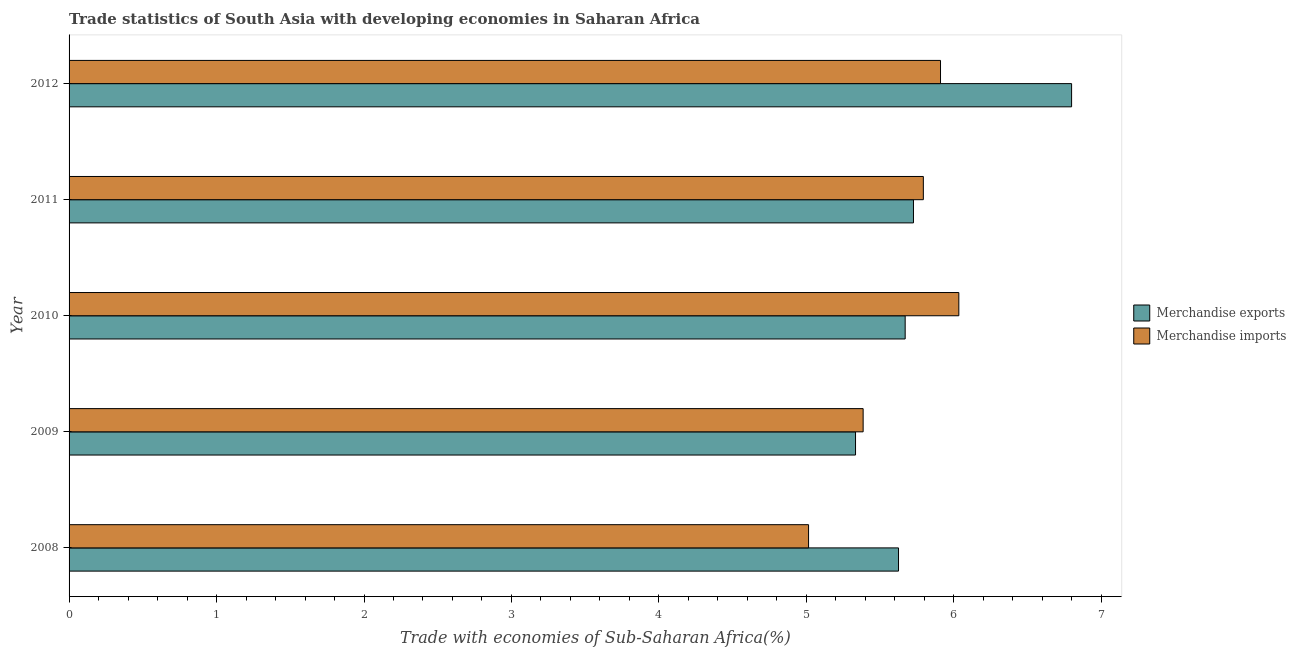How many different coloured bars are there?
Offer a terse response. 2. Are the number of bars on each tick of the Y-axis equal?
Ensure brevity in your answer.  Yes. How many bars are there on the 4th tick from the top?
Provide a succinct answer. 2. What is the label of the 2nd group of bars from the top?
Your answer should be compact. 2011. What is the merchandise exports in 2010?
Your answer should be compact. 5.67. Across all years, what is the maximum merchandise exports?
Keep it short and to the point. 6.8. Across all years, what is the minimum merchandise imports?
Your response must be concise. 5.01. In which year was the merchandise imports maximum?
Offer a terse response. 2010. In which year was the merchandise imports minimum?
Your answer should be compact. 2008. What is the total merchandise exports in the graph?
Provide a short and direct response. 29.15. What is the difference between the merchandise imports in 2010 and that in 2011?
Your answer should be compact. 0.24. What is the difference between the merchandise imports in 2008 and the merchandise exports in 2012?
Your answer should be compact. -1.78. What is the average merchandise exports per year?
Your response must be concise. 5.83. In the year 2008, what is the difference between the merchandise imports and merchandise exports?
Offer a very short reply. -0.61. In how many years, is the merchandise imports greater than 6.2 %?
Keep it short and to the point. 0. What is the ratio of the merchandise imports in 2008 to that in 2012?
Make the answer very short. 0.85. Is the merchandise exports in 2008 less than that in 2011?
Provide a short and direct response. Yes. Is the difference between the merchandise exports in 2011 and 2012 greater than the difference between the merchandise imports in 2011 and 2012?
Offer a terse response. No. What is the difference between the highest and the second highest merchandise imports?
Offer a very short reply. 0.12. What is the difference between the highest and the lowest merchandise exports?
Keep it short and to the point. 1.47. Is the sum of the merchandise imports in 2009 and 2010 greater than the maximum merchandise exports across all years?
Make the answer very short. Yes. What does the 2nd bar from the bottom in 2012 represents?
Keep it short and to the point. Merchandise imports. How many bars are there?
Give a very brief answer. 10. How many years are there in the graph?
Keep it short and to the point. 5. Where does the legend appear in the graph?
Your answer should be compact. Center right. How many legend labels are there?
Your answer should be compact. 2. What is the title of the graph?
Offer a very short reply. Trade statistics of South Asia with developing economies in Saharan Africa. Does "Primary education" appear as one of the legend labels in the graph?
Offer a terse response. No. What is the label or title of the X-axis?
Give a very brief answer. Trade with economies of Sub-Saharan Africa(%). What is the label or title of the Y-axis?
Keep it short and to the point. Year. What is the Trade with economies of Sub-Saharan Africa(%) of Merchandise exports in 2008?
Keep it short and to the point. 5.62. What is the Trade with economies of Sub-Saharan Africa(%) in Merchandise imports in 2008?
Ensure brevity in your answer.  5.01. What is the Trade with economies of Sub-Saharan Africa(%) in Merchandise exports in 2009?
Provide a short and direct response. 5.33. What is the Trade with economies of Sub-Saharan Africa(%) in Merchandise imports in 2009?
Your answer should be compact. 5.38. What is the Trade with economies of Sub-Saharan Africa(%) in Merchandise exports in 2010?
Give a very brief answer. 5.67. What is the Trade with economies of Sub-Saharan Africa(%) of Merchandise imports in 2010?
Offer a terse response. 6.03. What is the Trade with economies of Sub-Saharan Africa(%) in Merchandise exports in 2011?
Keep it short and to the point. 5.73. What is the Trade with economies of Sub-Saharan Africa(%) of Merchandise imports in 2011?
Your answer should be very brief. 5.79. What is the Trade with economies of Sub-Saharan Africa(%) in Merchandise exports in 2012?
Ensure brevity in your answer.  6.8. What is the Trade with economies of Sub-Saharan Africa(%) of Merchandise imports in 2012?
Make the answer very short. 5.91. Across all years, what is the maximum Trade with economies of Sub-Saharan Africa(%) of Merchandise exports?
Offer a terse response. 6.8. Across all years, what is the maximum Trade with economies of Sub-Saharan Africa(%) in Merchandise imports?
Provide a succinct answer. 6.03. Across all years, what is the minimum Trade with economies of Sub-Saharan Africa(%) in Merchandise exports?
Ensure brevity in your answer.  5.33. Across all years, what is the minimum Trade with economies of Sub-Saharan Africa(%) of Merchandise imports?
Your answer should be very brief. 5.01. What is the total Trade with economies of Sub-Saharan Africa(%) of Merchandise exports in the graph?
Provide a succinct answer. 29.15. What is the total Trade with economies of Sub-Saharan Africa(%) of Merchandise imports in the graph?
Offer a terse response. 28.14. What is the difference between the Trade with economies of Sub-Saharan Africa(%) of Merchandise exports in 2008 and that in 2009?
Provide a short and direct response. 0.29. What is the difference between the Trade with economies of Sub-Saharan Africa(%) in Merchandise imports in 2008 and that in 2009?
Keep it short and to the point. -0.37. What is the difference between the Trade with economies of Sub-Saharan Africa(%) in Merchandise exports in 2008 and that in 2010?
Make the answer very short. -0.05. What is the difference between the Trade with economies of Sub-Saharan Africa(%) in Merchandise imports in 2008 and that in 2010?
Offer a very short reply. -1.02. What is the difference between the Trade with economies of Sub-Saharan Africa(%) in Merchandise exports in 2008 and that in 2011?
Provide a succinct answer. -0.1. What is the difference between the Trade with economies of Sub-Saharan Africa(%) of Merchandise imports in 2008 and that in 2011?
Your answer should be compact. -0.78. What is the difference between the Trade with economies of Sub-Saharan Africa(%) in Merchandise exports in 2008 and that in 2012?
Give a very brief answer. -1.17. What is the difference between the Trade with economies of Sub-Saharan Africa(%) of Merchandise imports in 2008 and that in 2012?
Make the answer very short. -0.89. What is the difference between the Trade with economies of Sub-Saharan Africa(%) of Merchandise exports in 2009 and that in 2010?
Your response must be concise. -0.34. What is the difference between the Trade with economies of Sub-Saharan Africa(%) in Merchandise imports in 2009 and that in 2010?
Make the answer very short. -0.65. What is the difference between the Trade with economies of Sub-Saharan Africa(%) in Merchandise exports in 2009 and that in 2011?
Ensure brevity in your answer.  -0.39. What is the difference between the Trade with economies of Sub-Saharan Africa(%) in Merchandise imports in 2009 and that in 2011?
Your response must be concise. -0.41. What is the difference between the Trade with economies of Sub-Saharan Africa(%) in Merchandise exports in 2009 and that in 2012?
Your response must be concise. -1.47. What is the difference between the Trade with economies of Sub-Saharan Africa(%) in Merchandise imports in 2009 and that in 2012?
Keep it short and to the point. -0.52. What is the difference between the Trade with economies of Sub-Saharan Africa(%) of Merchandise exports in 2010 and that in 2011?
Offer a terse response. -0.06. What is the difference between the Trade with economies of Sub-Saharan Africa(%) in Merchandise imports in 2010 and that in 2011?
Ensure brevity in your answer.  0.24. What is the difference between the Trade with economies of Sub-Saharan Africa(%) in Merchandise exports in 2010 and that in 2012?
Offer a terse response. -1.13. What is the difference between the Trade with economies of Sub-Saharan Africa(%) in Merchandise imports in 2010 and that in 2012?
Offer a very short reply. 0.12. What is the difference between the Trade with economies of Sub-Saharan Africa(%) of Merchandise exports in 2011 and that in 2012?
Make the answer very short. -1.07. What is the difference between the Trade with economies of Sub-Saharan Africa(%) of Merchandise imports in 2011 and that in 2012?
Your answer should be very brief. -0.12. What is the difference between the Trade with economies of Sub-Saharan Africa(%) in Merchandise exports in 2008 and the Trade with economies of Sub-Saharan Africa(%) in Merchandise imports in 2009?
Your answer should be compact. 0.24. What is the difference between the Trade with economies of Sub-Saharan Africa(%) of Merchandise exports in 2008 and the Trade with economies of Sub-Saharan Africa(%) of Merchandise imports in 2010?
Keep it short and to the point. -0.41. What is the difference between the Trade with economies of Sub-Saharan Africa(%) of Merchandise exports in 2008 and the Trade with economies of Sub-Saharan Africa(%) of Merchandise imports in 2011?
Your answer should be very brief. -0.17. What is the difference between the Trade with economies of Sub-Saharan Africa(%) of Merchandise exports in 2008 and the Trade with economies of Sub-Saharan Africa(%) of Merchandise imports in 2012?
Offer a terse response. -0.28. What is the difference between the Trade with economies of Sub-Saharan Africa(%) of Merchandise exports in 2009 and the Trade with economies of Sub-Saharan Africa(%) of Merchandise imports in 2010?
Your response must be concise. -0.7. What is the difference between the Trade with economies of Sub-Saharan Africa(%) in Merchandise exports in 2009 and the Trade with economies of Sub-Saharan Africa(%) in Merchandise imports in 2011?
Offer a terse response. -0.46. What is the difference between the Trade with economies of Sub-Saharan Africa(%) in Merchandise exports in 2009 and the Trade with economies of Sub-Saharan Africa(%) in Merchandise imports in 2012?
Offer a very short reply. -0.58. What is the difference between the Trade with economies of Sub-Saharan Africa(%) in Merchandise exports in 2010 and the Trade with economies of Sub-Saharan Africa(%) in Merchandise imports in 2011?
Make the answer very short. -0.12. What is the difference between the Trade with economies of Sub-Saharan Africa(%) in Merchandise exports in 2010 and the Trade with economies of Sub-Saharan Africa(%) in Merchandise imports in 2012?
Offer a very short reply. -0.24. What is the difference between the Trade with economies of Sub-Saharan Africa(%) in Merchandise exports in 2011 and the Trade with economies of Sub-Saharan Africa(%) in Merchandise imports in 2012?
Your answer should be compact. -0.18. What is the average Trade with economies of Sub-Saharan Africa(%) of Merchandise exports per year?
Give a very brief answer. 5.83. What is the average Trade with economies of Sub-Saharan Africa(%) in Merchandise imports per year?
Your answer should be very brief. 5.63. In the year 2008, what is the difference between the Trade with economies of Sub-Saharan Africa(%) of Merchandise exports and Trade with economies of Sub-Saharan Africa(%) of Merchandise imports?
Offer a very short reply. 0.61. In the year 2009, what is the difference between the Trade with economies of Sub-Saharan Africa(%) of Merchandise exports and Trade with economies of Sub-Saharan Africa(%) of Merchandise imports?
Your response must be concise. -0.05. In the year 2010, what is the difference between the Trade with economies of Sub-Saharan Africa(%) in Merchandise exports and Trade with economies of Sub-Saharan Africa(%) in Merchandise imports?
Your answer should be compact. -0.36. In the year 2011, what is the difference between the Trade with economies of Sub-Saharan Africa(%) in Merchandise exports and Trade with economies of Sub-Saharan Africa(%) in Merchandise imports?
Offer a very short reply. -0.07. In the year 2012, what is the difference between the Trade with economies of Sub-Saharan Africa(%) of Merchandise exports and Trade with economies of Sub-Saharan Africa(%) of Merchandise imports?
Give a very brief answer. 0.89. What is the ratio of the Trade with economies of Sub-Saharan Africa(%) of Merchandise exports in 2008 to that in 2009?
Your answer should be compact. 1.05. What is the ratio of the Trade with economies of Sub-Saharan Africa(%) in Merchandise imports in 2008 to that in 2009?
Offer a very short reply. 0.93. What is the ratio of the Trade with economies of Sub-Saharan Africa(%) of Merchandise imports in 2008 to that in 2010?
Offer a very short reply. 0.83. What is the ratio of the Trade with economies of Sub-Saharan Africa(%) in Merchandise exports in 2008 to that in 2011?
Ensure brevity in your answer.  0.98. What is the ratio of the Trade with economies of Sub-Saharan Africa(%) in Merchandise imports in 2008 to that in 2011?
Your answer should be compact. 0.87. What is the ratio of the Trade with economies of Sub-Saharan Africa(%) in Merchandise exports in 2008 to that in 2012?
Offer a very short reply. 0.83. What is the ratio of the Trade with economies of Sub-Saharan Africa(%) of Merchandise imports in 2008 to that in 2012?
Offer a terse response. 0.85. What is the ratio of the Trade with economies of Sub-Saharan Africa(%) in Merchandise exports in 2009 to that in 2010?
Make the answer very short. 0.94. What is the ratio of the Trade with economies of Sub-Saharan Africa(%) in Merchandise imports in 2009 to that in 2010?
Make the answer very short. 0.89. What is the ratio of the Trade with economies of Sub-Saharan Africa(%) of Merchandise exports in 2009 to that in 2011?
Give a very brief answer. 0.93. What is the ratio of the Trade with economies of Sub-Saharan Africa(%) of Merchandise imports in 2009 to that in 2011?
Provide a succinct answer. 0.93. What is the ratio of the Trade with economies of Sub-Saharan Africa(%) of Merchandise exports in 2009 to that in 2012?
Offer a very short reply. 0.78. What is the ratio of the Trade with economies of Sub-Saharan Africa(%) of Merchandise imports in 2009 to that in 2012?
Your answer should be compact. 0.91. What is the ratio of the Trade with economies of Sub-Saharan Africa(%) of Merchandise exports in 2010 to that in 2011?
Your answer should be compact. 0.99. What is the ratio of the Trade with economies of Sub-Saharan Africa(%) of Merchandise imports in 2010 to that in 2011?
Provide a short and direct response. 1.04. What is the ratio of the Trade with economies of Sub-Saharan Africa(%) of Merchandise exports in 2010 to that in 2012?
Make the answer very short. 0.83. What is the ratio of the Trade with economies of Sub-Saharan Africa(%) of Merchandise exports in 2011 to that in 2012?
Give a very brief answer. 0.84. What is the ratio of the Trade with economies of Sub-Saharan Africa(%) of Merchandise imports in 2011 to that in 2012?
Offer a very short reply. 0.98. What is the difference between the highest and the second highest Trade with economies of Sub-Saharan Africa(%) in Merchandise exports?
Make the answer very short. 1.07. What is the difference between the highest and the second highest Trade with economies of Sub-Saharan Africa(%) of Merchandise imports?
Provide a succinct answer. 0.12. What is the difference between the highest and the lowest Trade with economies of Sub-Saharan Africa(%) of Merchandise exports?
Your answer should be compact. 1.47. 